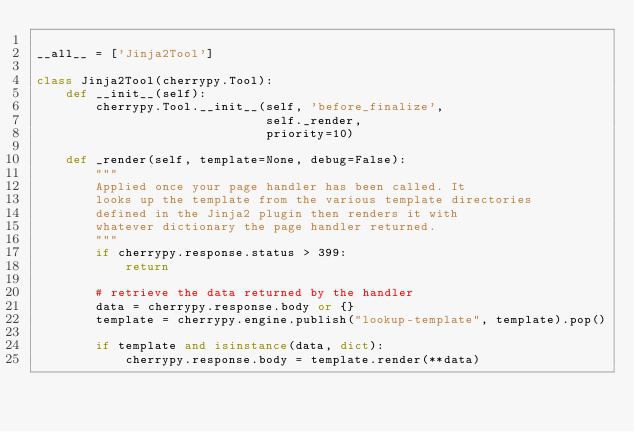Convert code to text. <code><loc_0><loc_0><loc_500><loc_500><_Python_>
__all__ = ['Jinja2Tool']

class Jinja2Tool(cherrypy.Tool):
    def __init__(self):
        cherrypy.Tool.__init__(self, 'before_finalize',
                               self._render,
                               priority=10)
        
    def _render(self, template=None, debug=False):
        """
        Applied once your page handler has been called. It
        looks up the template from the various template directories
        defined in the Jinja2 plugin then renders it with
        whatever dictionary the page handler returned.
        """
        if cherrypy.response.status > 399:
            return

        # retrieve the data returned by the handler
        data = cherrypy.response.body or {}
        template = cherrypy.engine.publish("lookup-template", template).pop()

        if template and isinstance(data, dict):
            cherrypy.response.body = template.render(**data)</code> 